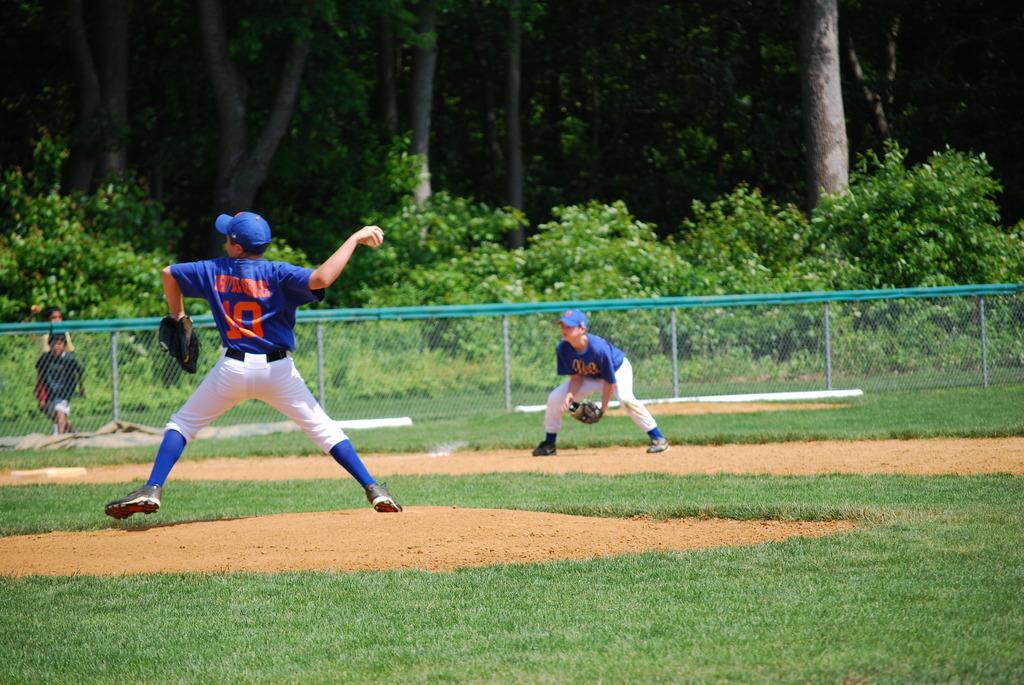In one or two sentences, can you explain what this image depicts? In the picture I can see a child wearing blue color T-shirt, cap, socks and shoes is in the air and is on the left side of the image. In the background, we can see another person wearing blue color T-shirt, cap, shoes and glove is standing on the ground. Here we can see the fence, two children walking on the ground on the left side of the image and we can see plants and trees. 